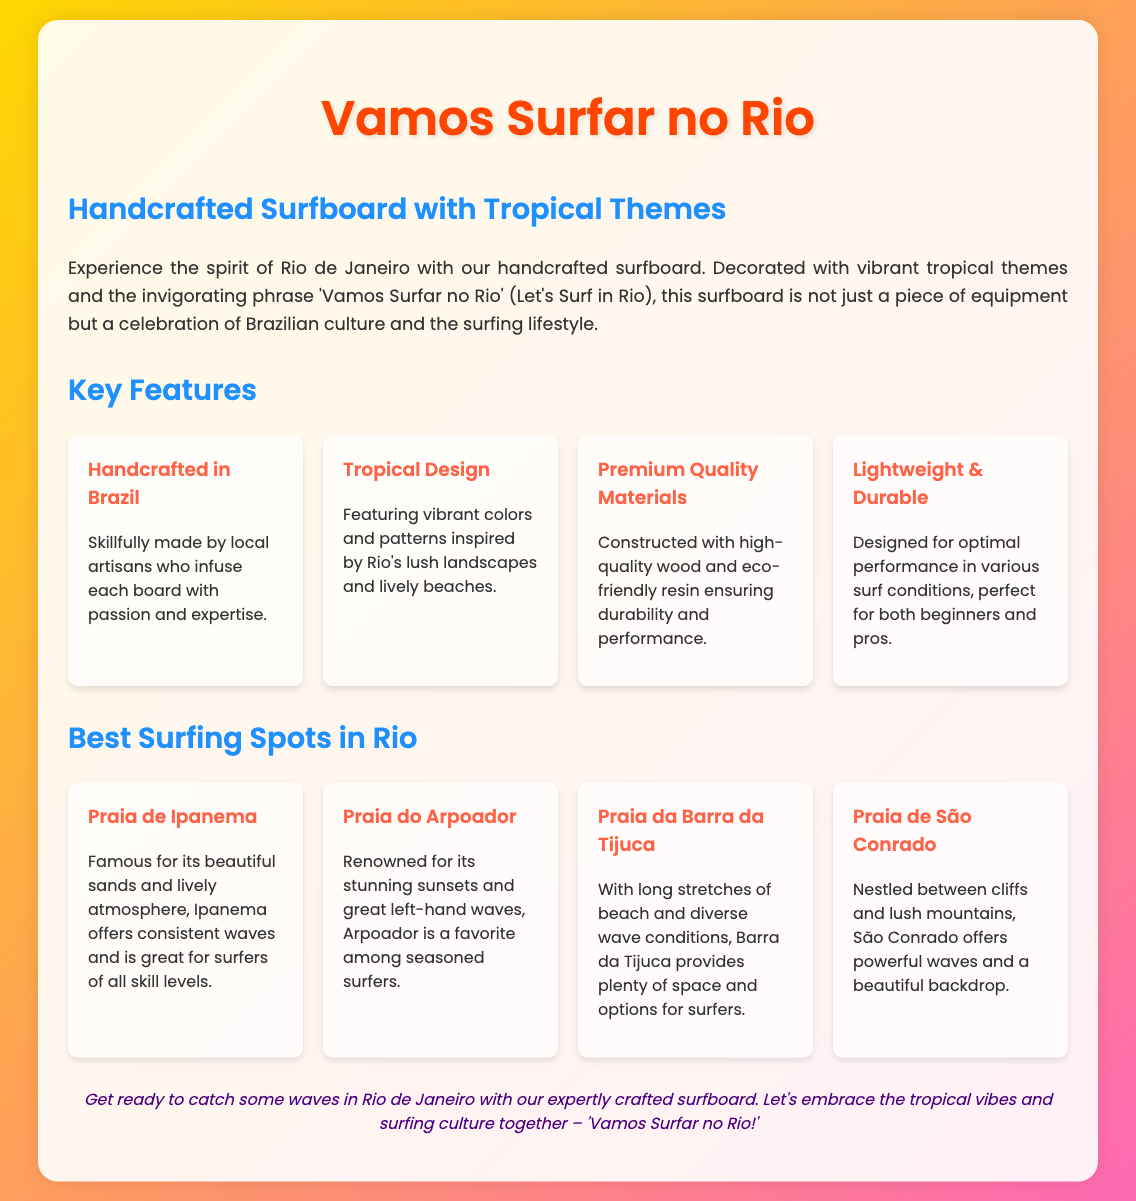What is the title of the product? The title of the product is prominently displayed at the top of the document.
Answer: Vamos Surfar no Rio Who handcrafted the surfboard? The document mentions that the surfboard is skillfully made by local artisans.
Answer: Local artisans What is the tropical phrase featured on the surfboard? The document explicitly states the phrase that decorates the surfboard.
Answer: Vamos Surfar no Rio Which surfing spot is famous for its beautiful sands? The document lists various surfing spots and highlights the one known for beautiful sands.
Answer: Praia de Ipanema How many key features are listed in the document? The document details several key features of the surfboard, specifically saying that there are 'Key Features' mentioned.
Answer: Four Which surfing spot is renowned for stunning sunsets? The document specifies one of the surfing spots recognized for its beautiful sunsets.
Answer: Praia do Arpoador What type of materials is used for the surfboard construction? The document describes the materials used in the surfboard's construction.
Answer: Premium Quality Materials Which beach provides diverse wave conditions for surfers? The document includes a surfing spot that is noted for its variety of wave conditions.
Answer: Praia da Barra da Tijuca 